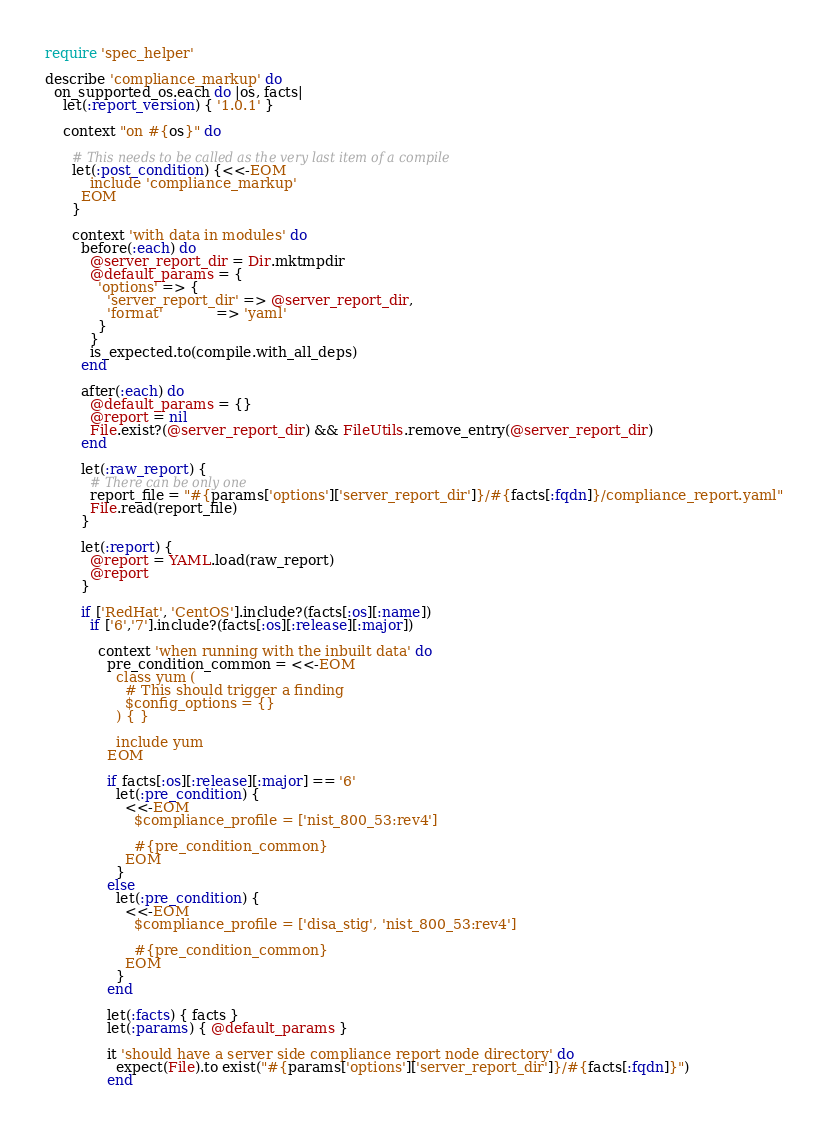Convert code to text. <code><loc_0><loc_0><loc_500><loc_500><_Ruby_>require 'spec_helper'

describe 'compliance_markup' do
  on_supported_os.each do |os, facts|
    let(:report_version) { '1.0.1' }

    context "on #{os}" do

      # This needs to be called as the very last item of a compile
      let(:post_condition) {<<-EOM
          include 'compliance_markup'
        EOM
      }

      context 'with data in modules' do
        before(:each) do
          @server_report_dir = Dir.mktmpdir
          @default_params = {
            'options' => {
              'server_report_dir' => @server_report_dir,
              'format'            => 'yaml'
            }
          }
          is_expected.to(compile.with_all_deps)
        end

        after(:each) do
          @default_params = {}
          @report = nil
          File.exist?(@server_report_dir) && FileUtils.remove_entry(@server_report_dir)
        end

        let(:raw_report) {
          # There can be only one
          report_file = "#{params['options']['server_report_dir']}/#{facts[:fqdn]}/compliance_report.yaml"
          File.read(report_file)
        }

        let(:report) {
          @report = YAML.load(raw_report)
          @report
        }

        if ['RedHat', 'CentOS'].include?(facts[:os][:name])
          if ['6','7'].include?(facts[:os][:release][:major])

            context 'when running with the inbuilt data' do
              pre_condition_common = <<-EOM
                class yum (
                  # This should trigger a finding
                  $config_options = {}
                ) { }

                include yum
              EOM

              if facts[:os][:release][:major] == '6'
                let(:pre_condition) {
                  <<-EOM
                    $compliance_profile = ['nist_800_53:rev4']

                    #{pre_condition_common}
                  EOM
                }
              else
                let(:pre_condition) {
                  <<-EOM
                    $compliance_profile = ['disa_stig', 'nist_800_53:rev4']

                    #{pre_condition_common}
                  EOM
                }
              end

              let(:facts) { facts }
              let(:params) { @default_params }

              it 'should have a server side compliance report node directory' do
                expect(File).to exist("#{params['options']['server_report_dir']}/#{facts[:fqdn]}")
              end
</code> 